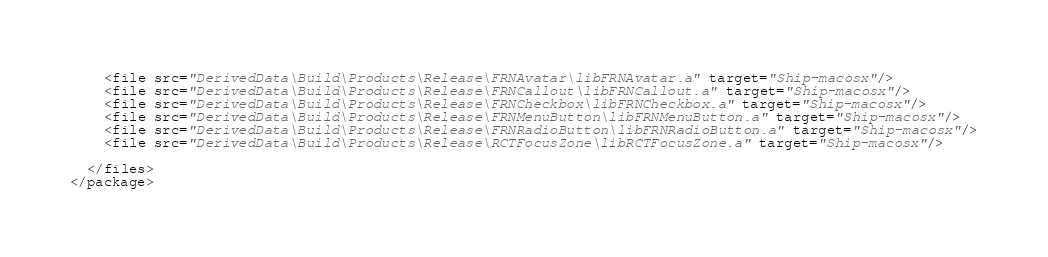<code> <loc_0><loc_0><loc_500><loc_500><_XML_>    <file src="DerivedData\Build\Products\Release\FRNAvatar\libFRNAvatar.a" target="Ship-macosx"/>
    <file src="DerivedData\Build\Products\Release\FRNCallout\libFRNCallout.a" target="Ship-macosx"/>
    <file src="DerivedData\Build\Products\Release\FRNCheckbox\libFRNCheckbox.a" target="Ship-macosx"/>
    <file src="DerivedData\Build\Products\Release\FRNMenuButton\libFRNMenuButton.a" target="Ship-macosx"/>
    <file src="DerivedData\Build\Products\Release\FRNRadioButton\libFRNRadioButton.a" target="Ship-macosx"/>
    <file src="DerivedData\Build\Products\Release\RCTFocusZone\libRCTFocusZone.a" target="Ship-macosx"/>

  </files>
</package>
</code> 